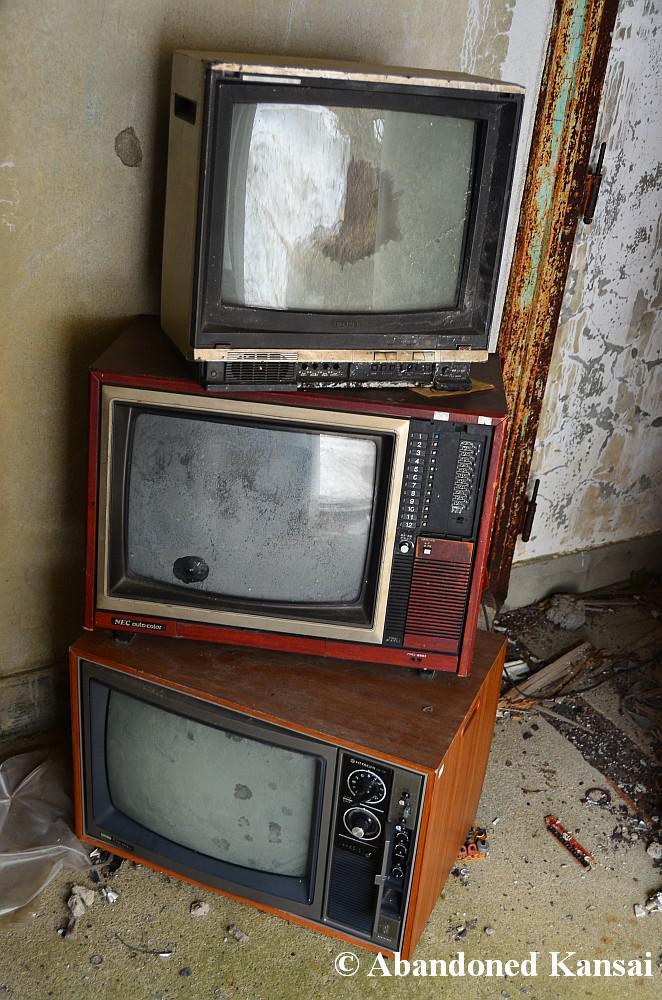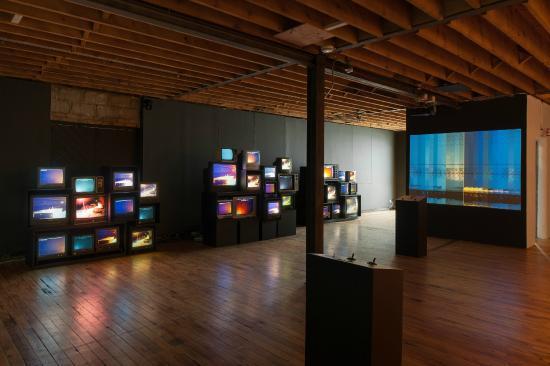The first image is the image on the left, the second image is the image on the right. Analyze the images presented: Is the assertion "One image shows an interior with an exposed beam ceiling and multiple stacks of televisions with pictures on their screens stacked along the lefthand wall." valid? Answer yes or no. Yes. The first image is the image on the left, the second image is the image on the right. For the images displayed, is the sentence "There are at least three televisions turned off." factually correct? Answer yes or no. Yes. 